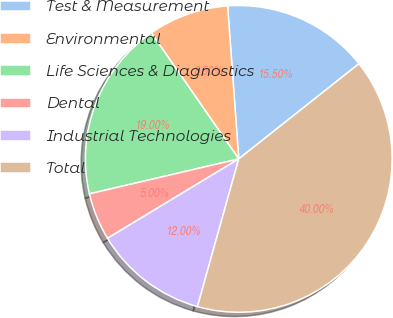<chart> <loc_0><loc_0><loc_500><loc_500><pie_chart><fcel>Test & Measurement<fcel>Environmental<fcel>Life Sciences & Diagnostics<fcel>Dental<fcel>Industrial Technologies<fcel>Total<nl><fcel>15.5%<fcel>8.5%<fcel>19.0%<fcel>5.0%<fcel>12.0%<fcel>40.0%<nl></chart> 